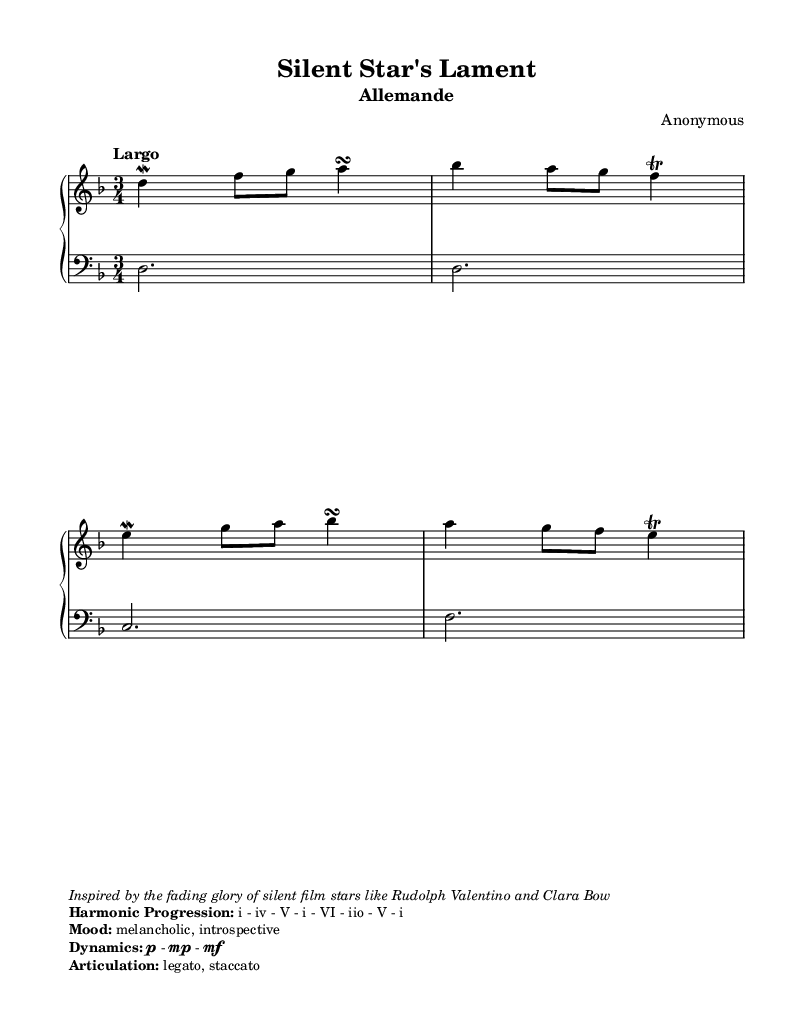What is the key signature of this music? The key signature is indicated by the number of sharps or flats at the beginning of the staff. In this case, there are no sharps or flats; thus, the key is D minor.
Answer: D minor What is the time signature of this music? The time signature is found at the beginning of the piece and indicates how many beats are in each measure. Here, it shows a 3 over 4, which means there are three beats per measure and each beat is a quarter note.
Answer: 3/4 What is the tempo marking of the piece? The tempo marking is typically written above the staff and specifies the speed of the music. Here, it says "Largo," indicating a slow and broad tempo.
Answer: Largo What is the mood indicated in the sheet music? The mood is expressed in the markup, where it states "melancholic, introspective." This reflects the emotional tone of the piece.
Answer: melancholic, introspective What is the harmonic progression outlined in the markup? The harmonic progression is listed in a bold format within the markup section of the music, and it provides a series of chords. The progression indicated here is: i - iv - V - i - VI - iio - V - i.
Answer: i - iv - V - i - VI - iio - V - i What is the dynamics indicated in the sheet music? The dynamics are described in the markup section, outlining the volume levels to be played. Here, it states "p - mp - mf," indicating specific dynamic levels from soft to moderately loud.
Answer: p - mp - mf What type of articulation is specified for this piece? The articulation markings describe how notes should be played, and in this case, the markup indicates "legato, staccato." This means to play smoothly connected (legato) or detached (staccato).
Answer: legato, staccato 